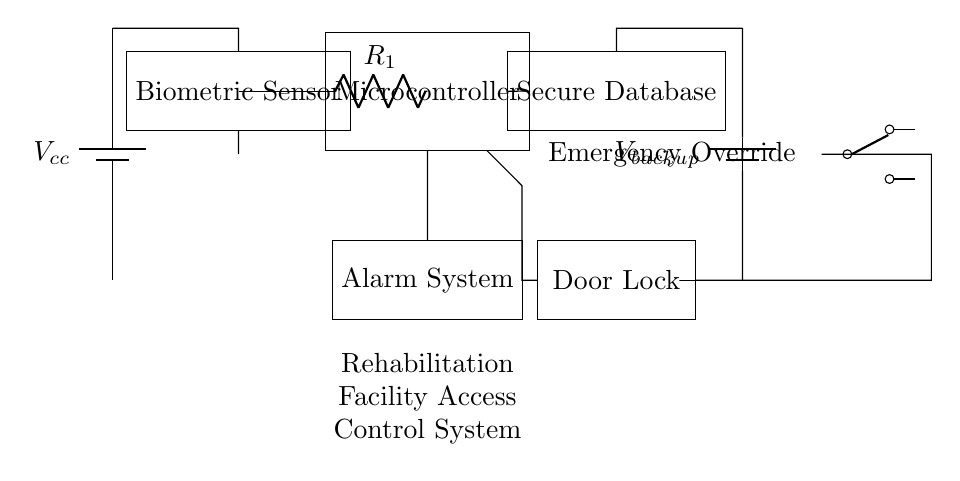What is the main power supply voltage? The main power supply is indicated as Vcc in the circuit diagram, which is commonly understood to represent the main operational voltage of the circuit.
Answer: Vcc What component connects the biometric sensor to the microcontroller? The circuit shows a resistor labeled R1 connecting the biometric sensor to the microcontroller, which allows for the data from the sensor to be transmitted to the controller effectively.
Answer: R1 What action does the alarm system perform? The alarm system’s function isn't explicitly detailed in the schematic, but it typically serves to alert personnel in case of unauthorized access, which is implied by its connection to the microcontroller.
Answer: Alert Which component ensures the lock can be overridden in emergencies? The presence of the emergency override switch in the circuit diagram allows for manual control over the door lock, facilitating access during emergencies regardless of the main control system.
Answer: Emergency Override How is backup power supplied to the secure database? The circuit diagram shows a backup battery labeled Vbackup that provides an independent power source to the secure database, ensuring it remains operational even if the main power supply fails.
Answer: Vbackup What key role does the microcontroller play in this circuit? The microcontroller acts as the central processing unit, managing inputs from the biometric sensor and issuing control signals to both the alarm system and the door lock, making it essential for the control logic of the access system.
Answer: Control logic 